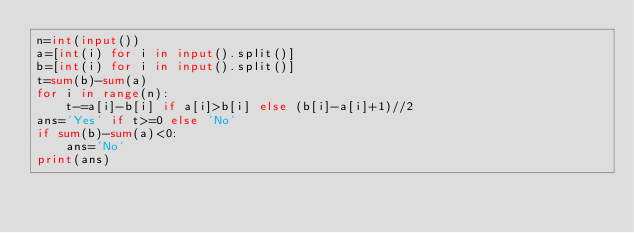<code> <loc_0><loc_0><loc_500><loc_500><_Python_>n=int(input())
a=[int(i) for i in input().split()]
b=[int(i) for i in input().split()]
t=sum(b)-sum(a)
for i in range(n):
    t-=a[i]-b[i] if a[i]>b[i] else (b[i]-a[i]+1)//2
ans='Yes' if t>=0 else 'No'
if sum(b)-sum(a)<0:
    ans='No'
print(ans)
</code> 